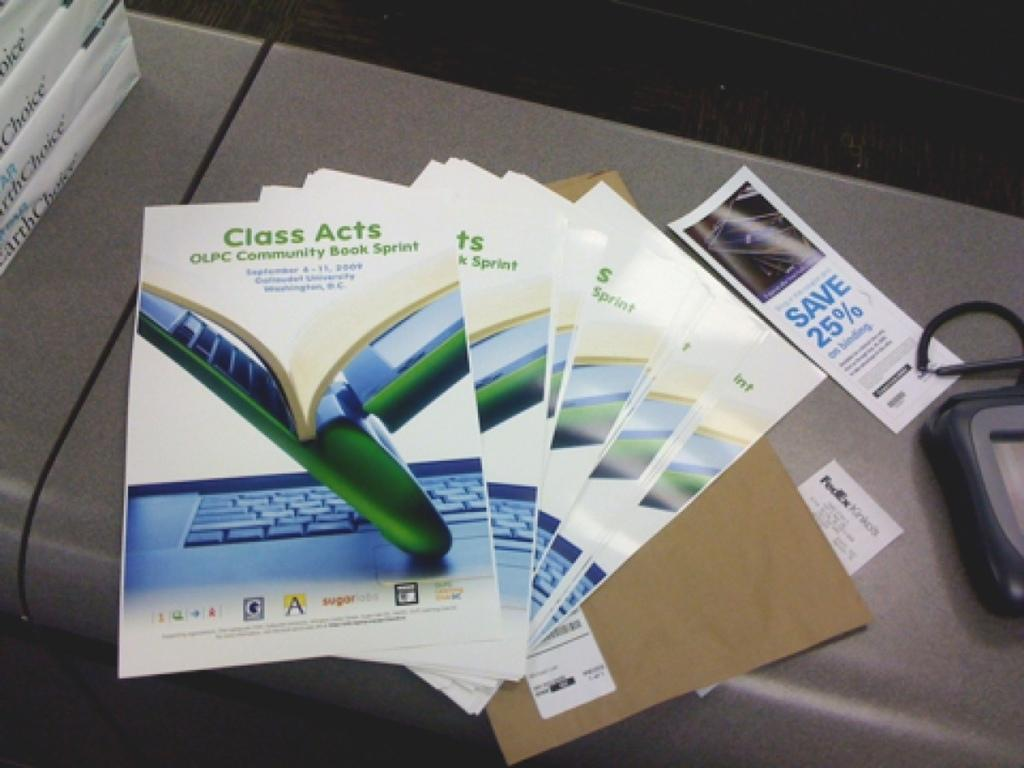<image>
Summarize the visual content of the image. Class Acts booklets placed on top of one another with a Save 25% coupon on the side. 